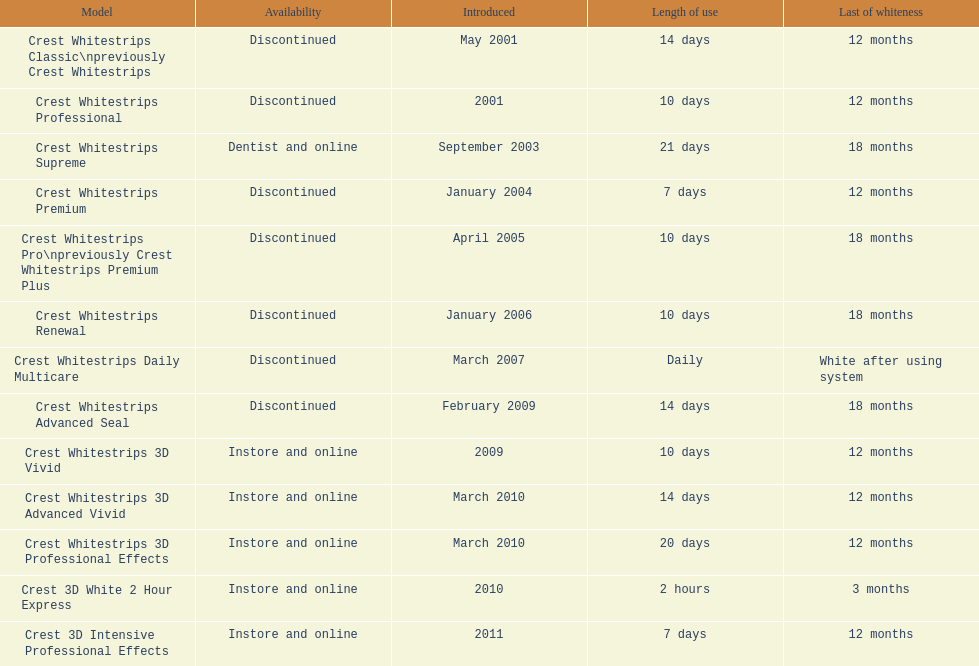Tell me the number of products that give you 12 months of whiteness. 7. 